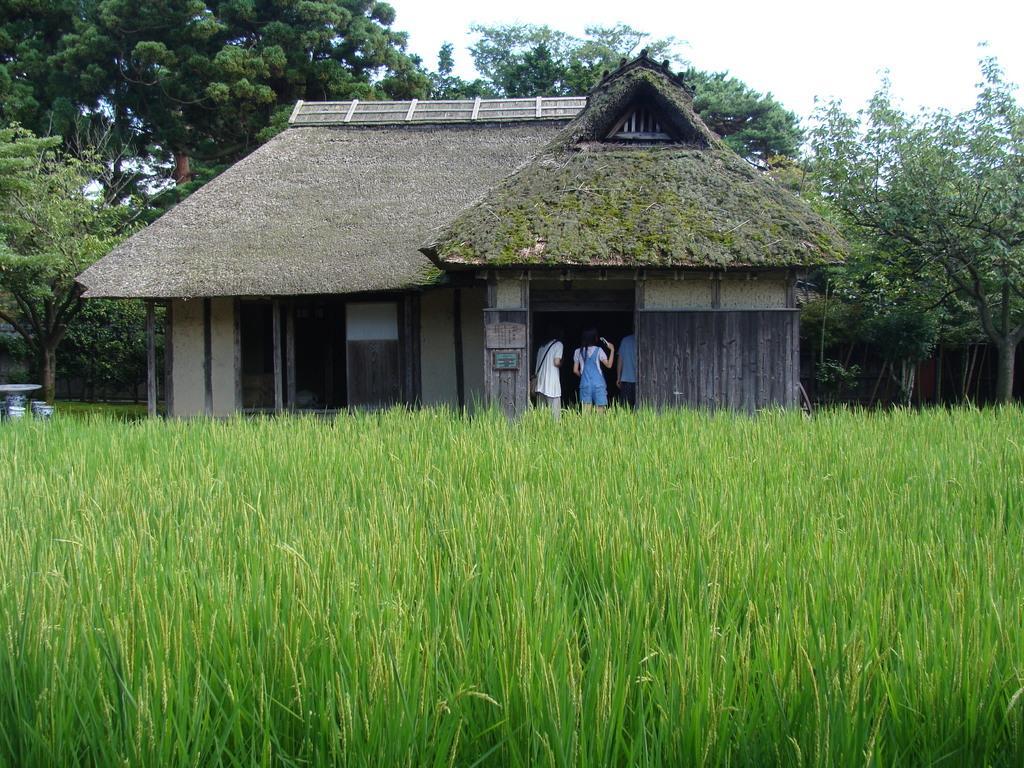Please provide a concise description of this image. In this picture I can observe some grass on the ground. There is house in the middle of the picture. I can observe some people in the house. In the background there are trees and a sky. 